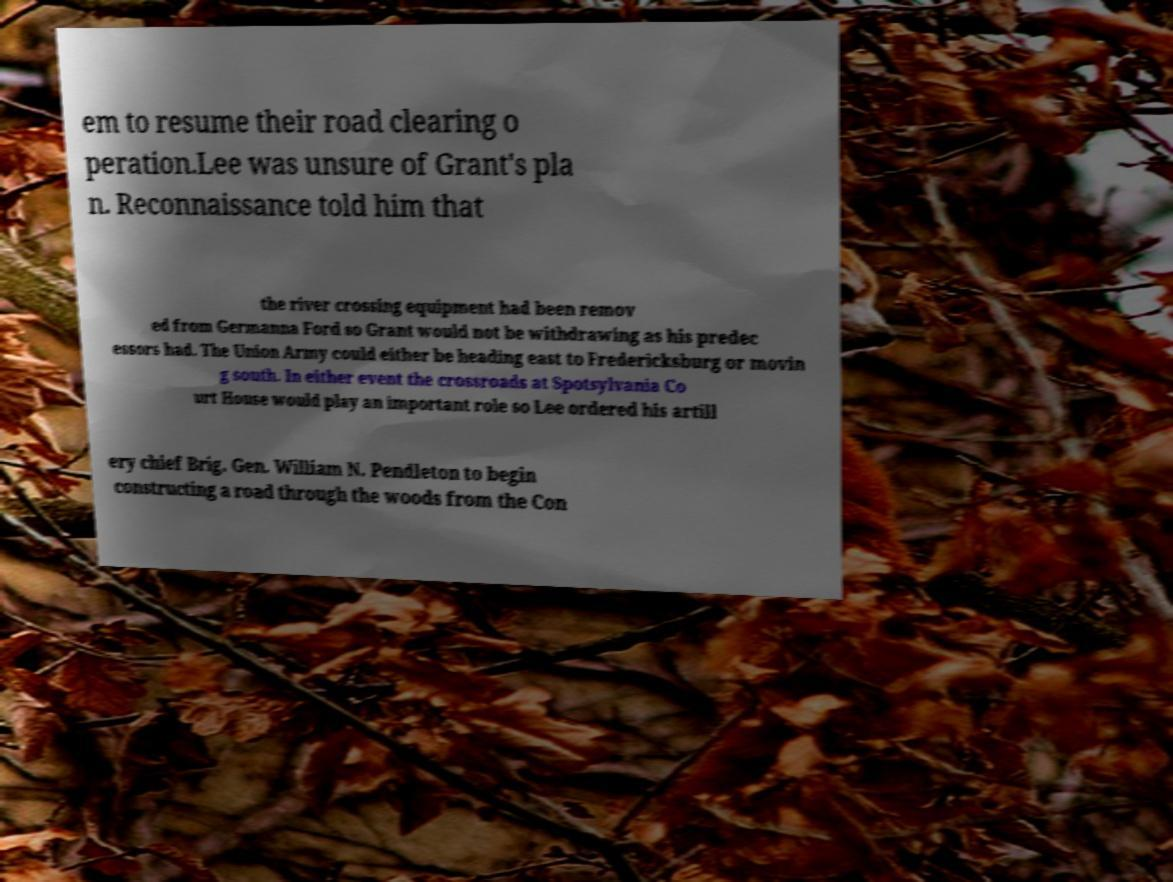Could you assist in decoding the text presented in this image and type it out clearly? em to resume their road clearing o peration.Lee was unsure of Grant's pla n. Reconnaissance told him that the river crossing equipment had been remov ed from Germanna Ford so Grant would not be withdrawing as his predec essors had. The Union Army could either be heading east to Fredericksburg or movin g south. In either event the crossroads at Spotsylvania Co urt House would play an important role so Lee ordered his artill ery chief Brig. Gen. William N. Pendleton to begin constructing a road through the woods from the Con 